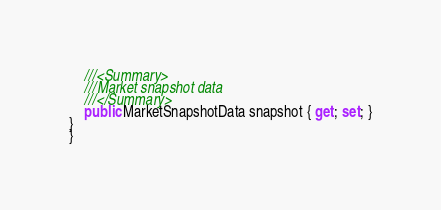Convert code to text. <code><loc_0><loc_0><loc_500><loc_500><_C#_>	///<Summary>
	///Market snapshot data
	///</Summary>
	public MarketSnapshotData snapshot { get; set; }
}
}
</code> 